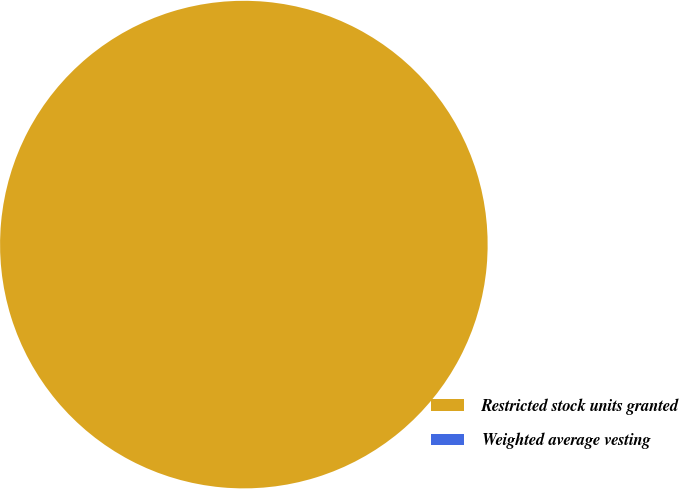<chart> <loc_0><loc_0><loc_500><loc_500><pie_chart><fcel>Restricted stock units granted<fcel>Weighted average vesting<nl><fcel>100.0%<fcel>0.0%<nl></chart> 